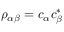<formula> <loc_0><loc_0><loc_500><loc_500>\rho _ { \alpha \beta } = c _ { \alpha } c _ { \beta } ^ { * }</formula> 